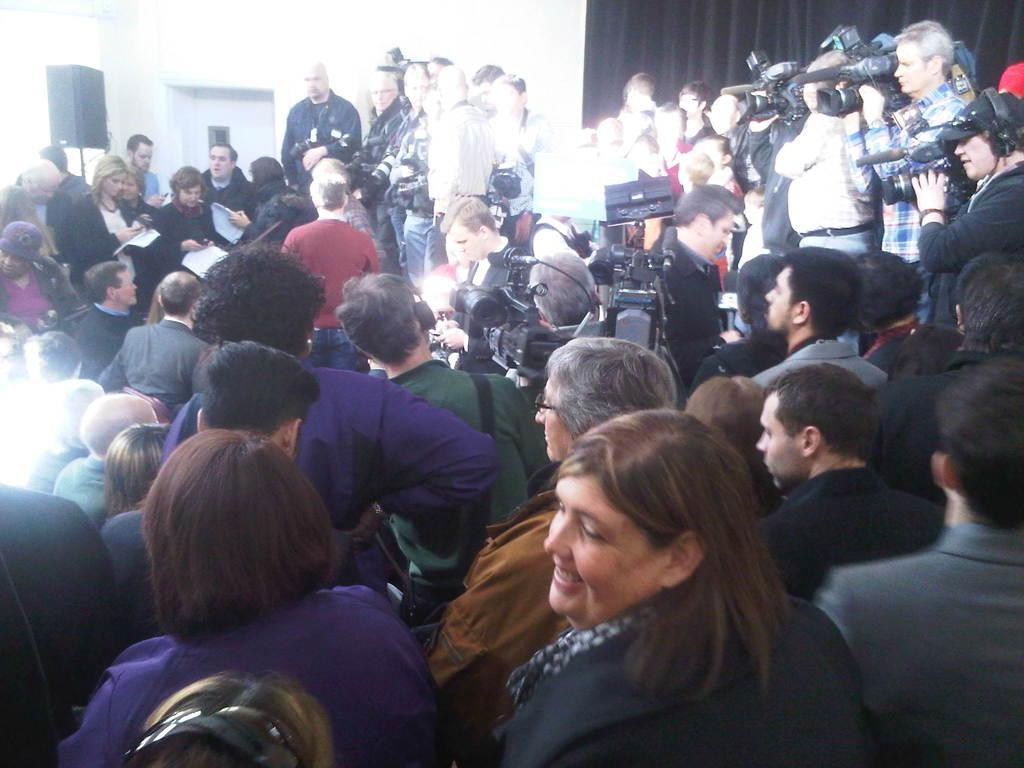In one or two sentences, can you explain what this image depicts? In this picture we can see many people standing in a place. In the center we can see many media persons recording the event using video cameras and microphones. 